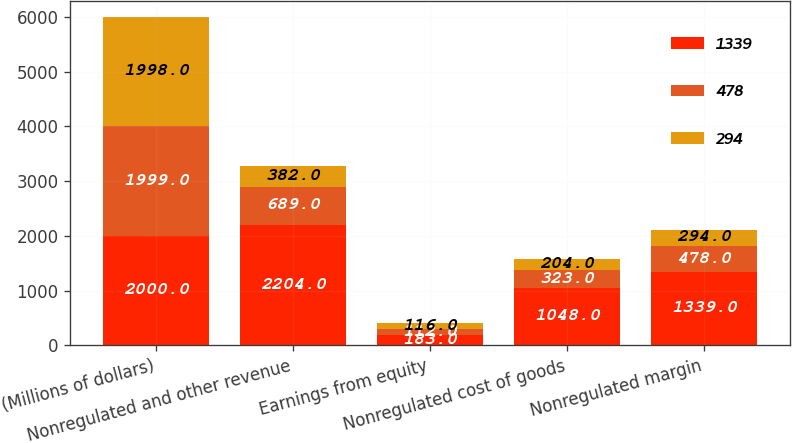Convert chart. <chart><loc_0><loc_0><loc_500><loc_500><stacked_bar_chart><ecel><fcel>(Millions of dollars)<fcel>Nonregulated and other revenue<fcel>Earnings from equity<fcel>Nonregulated cost of goods<fcel>Nonregulated margin<nl><fcel>1339<fcel>2000<fcel>2204<fcel>183<fcel>1048<fcel>1339<nl><fcel>478<fcel>1999<fcel>689<fcel>112<fcel>323<fcel>478<nl><fcel>294<fcel>1998<fcel>382<fcel>116<fcel>204<fcel>294<nl></chart> 